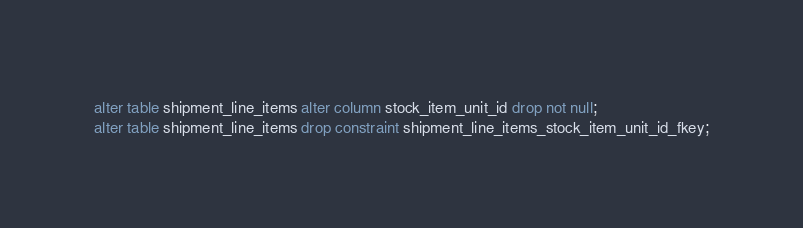Convert code to text. <code><loc_0><loc_0><loc_500><loc_500><_SQL_>alter table shipment_line_items alter column stock_item_unit_id drop not null;
alter table shipment_line_items drop constraint shipment_line_items_stock_item_unit_id_fkey;
</code> 